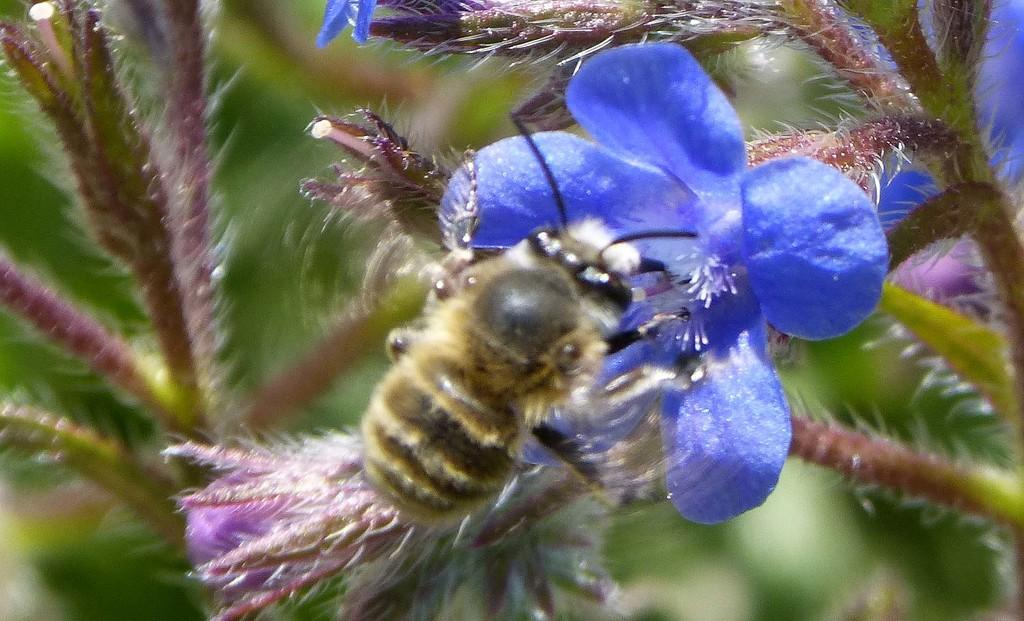What is on the flower in the image? There is an insect on a flower in the image. What else can be seen in the image besides the insect and flower? There are stems visible in the image. How would you describe the background of the image? The background of the image is blurry. What time does the grandfather clock chime in the image? There is no grandfather clock present in the image. 